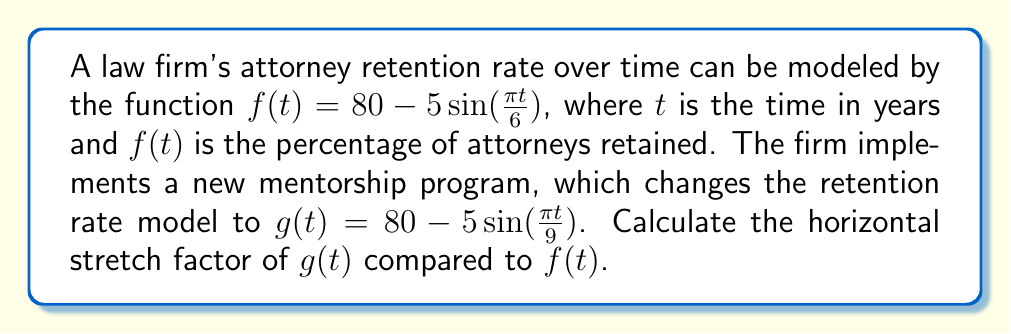Can you solve this math problem? To determine the horizontal stretch factor, we need to compare the periods of the sine functions in $f(t)$ and $g(t)$.

1) For $f(t)$, the period is determined by $\frac{\pi t}{6}$:
   $$2\pi = \frac{\pi t}{6}$$
   $$t = 12$$
   So, the period of $f(t)$ is 12 years.

2) For $g(t)$, the period is determined by $\frac{\pi t}{9}$:
   $$2\pi = \frac{\pi t}{9}$$
   $$t = 18$$
   So, the period of $g(t)$ is 18 years.

3) The horizontal stretch factor is the ratio of the new period to the original period:
   $$\text{Stretch factor} = \frac{\text{New period}}{\text{Original period}} = \frac{18}{12} = \frac{3}{2} = 1.5$$

This means that $g(t)$ is a horizontal stretch of $f(t)$ by a factor of 1.5.

In the context of attorney retention, this indicates that the new mentorship program has extended the cycle of retention rate fluctuations, potentially providing more stability over time.
Answer: The horizontal stretch factor is 1.5. 